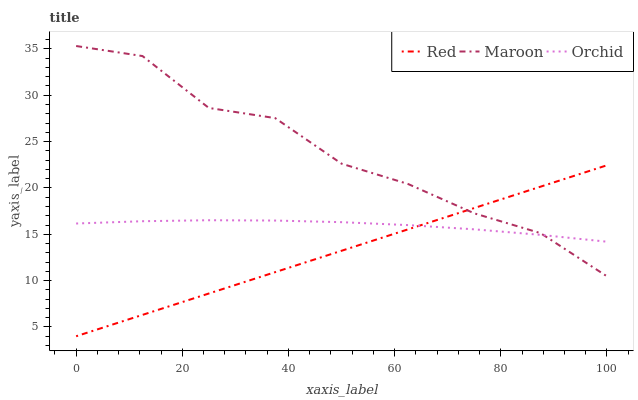Does Red have the minimum area under the curve?
Answer yes or no. Yes. Does Orchid have the minimum area under the curve?
Answer yes or no. No. Does Orchid have the maximum area under the curve?
Answer yes or no. No. Is Maroon the roughest?
Answer yes or no. Yes. Is Orchid the smoothest?
Answer yes or no. No. Is Orchid the roughest?
Answer yes or no. No. Does Orchid have the lowest value?
Answer yes or no. No. Does Red have the highest value?
Answer yes or no. No. 